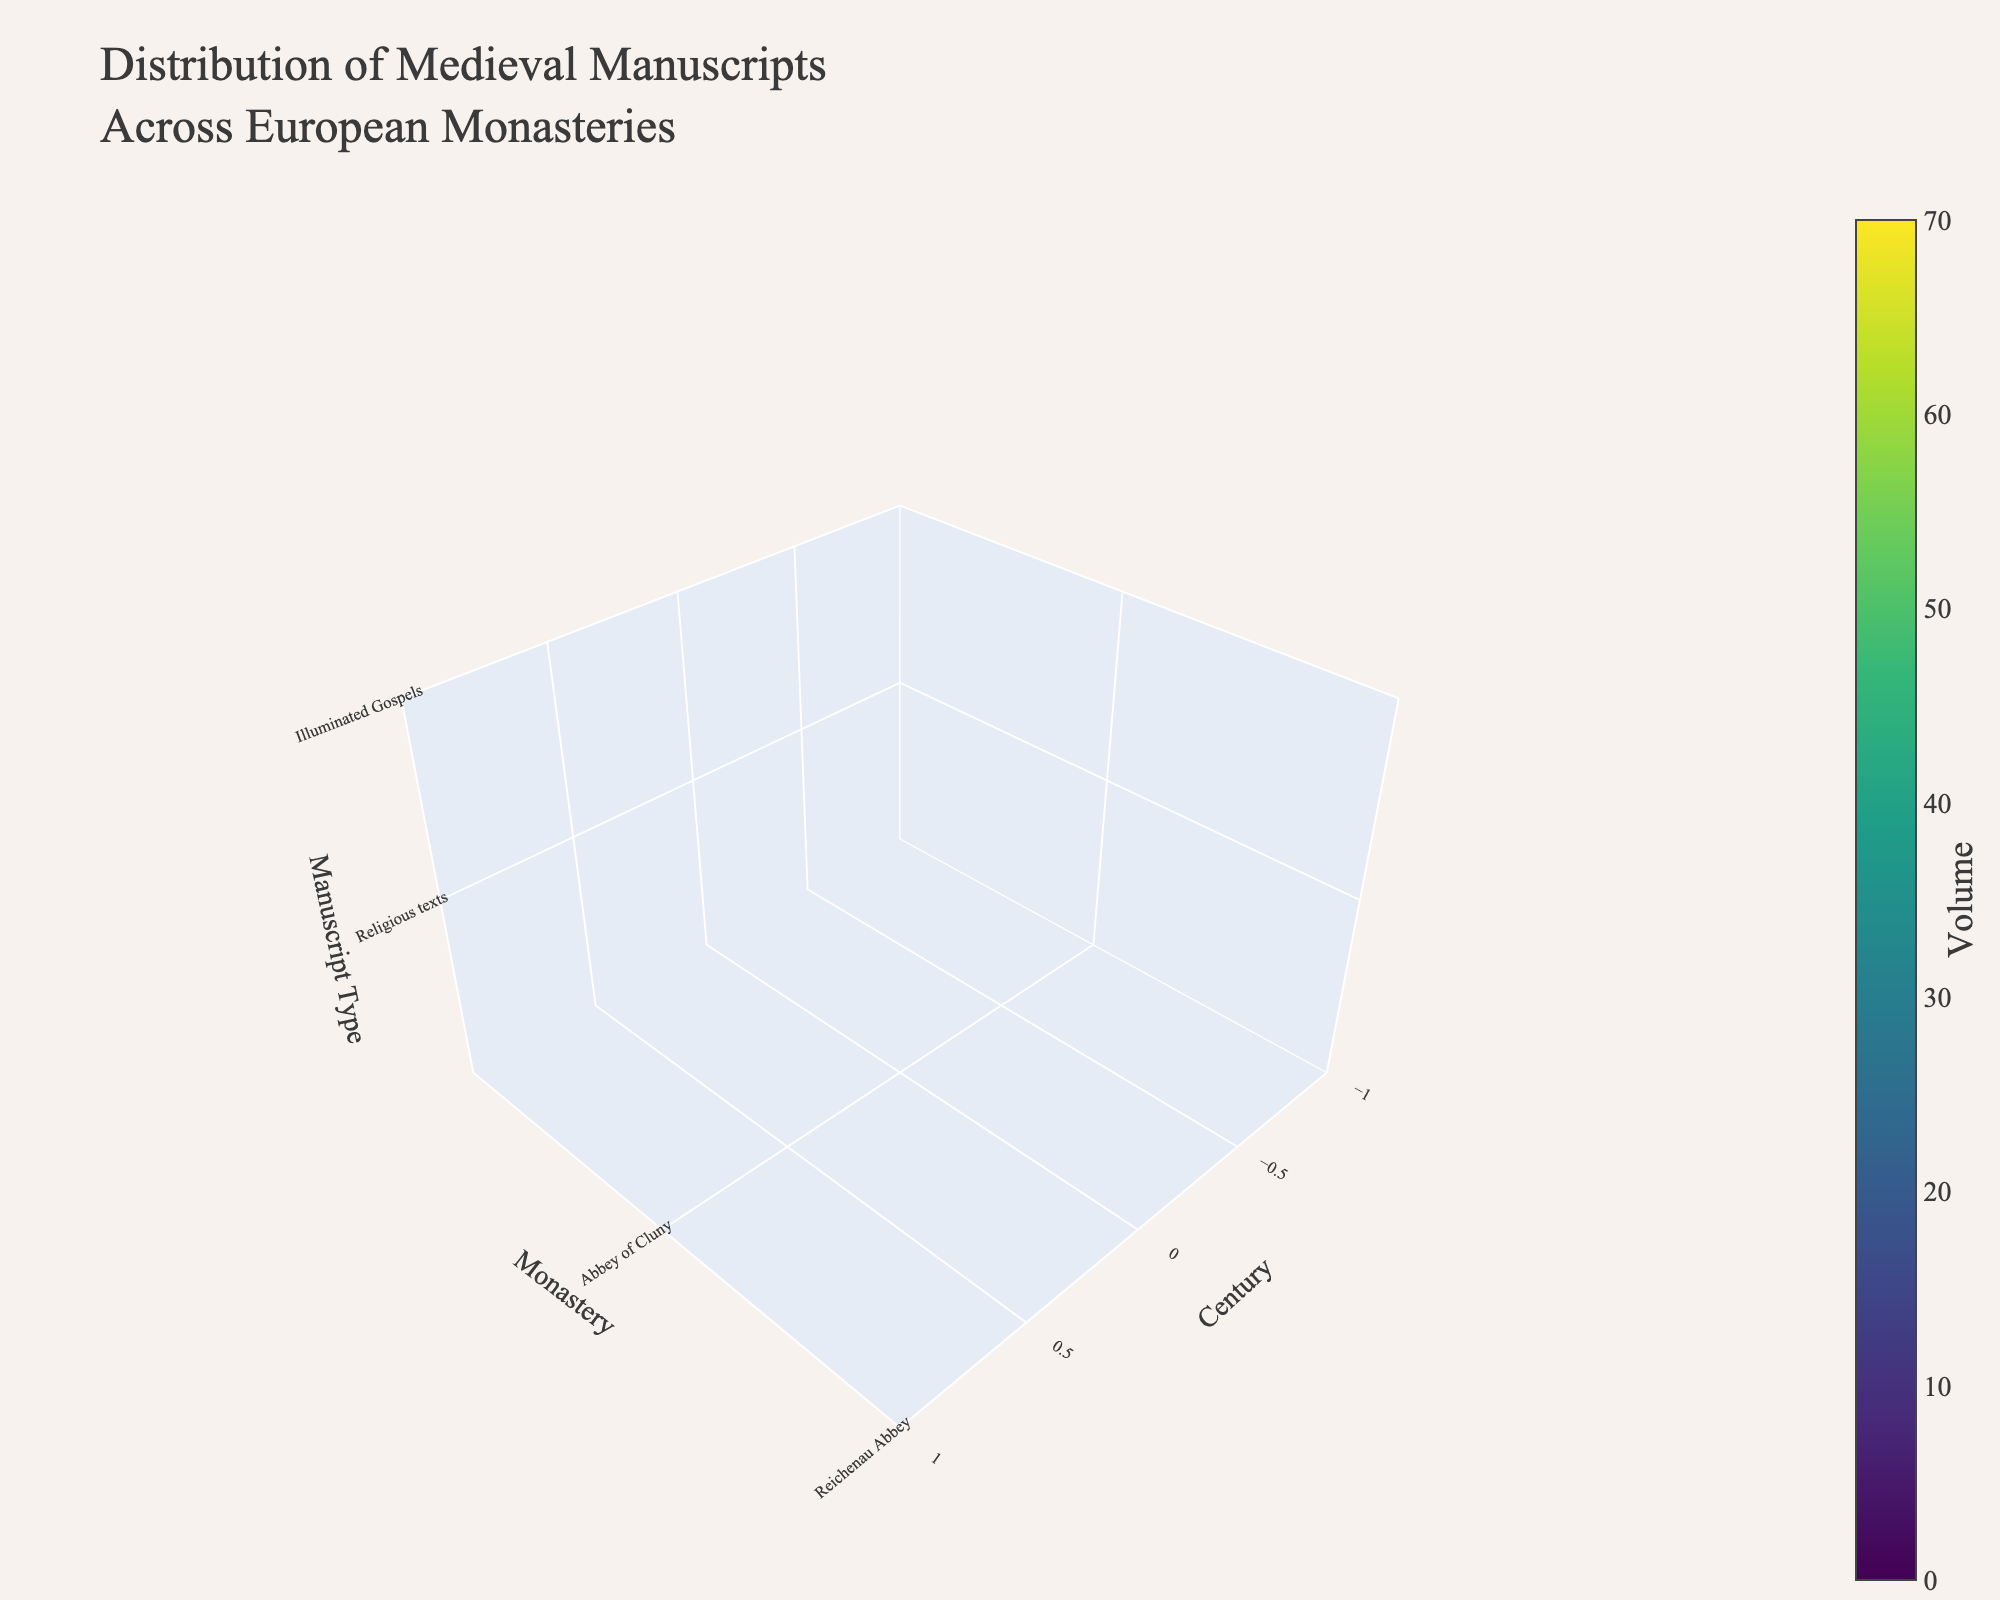How many centuries are represented in the plot? The plot's x-axis is labeled "Century" and spans across multiple points. By observing these points, one can count the distinct centuries.
Answer: 5 Which monastery has the highest volume of manuscripts in the 12th century? Locate the data points corresponding to the 12th century (x-axis) and identify the highest volume (color intensity) among the monasteries (y-axis).
Answer: Scriptorium of St. Gall How does the volume of illuminated gospels in Reichenau Abbey in the 11th century compare to the volume of liturgical books in the Scriptorium of St. Gall in the 12th century? Compare the volumes for the given monastery and manuscript type across the specified centuries by examining the color intensities at the respective 3D coordinates.
Answer: 32 (Reichenau Abbey, 11th century) < 58 (Scriptorium of St. Gall, 12th century) What's the average volume of manuscripts in the 13th century? For the 13th century, locate all the data points, sum their volumes, and divide by the number of data points. (63 + 41 + 35) / 3 = 139 / 3.
Answer: 46.33 Which century has the greatest variety of manuscript types represented? Look at the z-axis (manuscript types) for each century and count the unique types per century to determine which has the most variety.
Answer: 14th century Which manuscript type has the highest overall volume across all centuries and monasteries? Sum the volumes for each manuscript type across all centuries and monasteries and identify the type with the highest total.
Answer: Humanist texts Compare the volumes of scientific manuscripts in the Monastery of Santa Maria de Ripoll (13th century) and astronomical works in Monastery of El Escorial (15th century). Locate these specific data points in the plot and compare the respective volumes.
Answer: 35 (Santa Maria de Ripoll, 13th century) < 43 (El Escorial, 15th century) What is the total volume of religious texts documented in the plot across all centuries and monasteries? Locate all the data points for "Religious texts" across the plot and sum their volumes.
Answer: 45 How do the volumes of devotional texts in the Franciscan Convent of Assisi in the 14th century and humanist texts in the Abbey of Saint-Victor in the 15th century compare? Check the respective volumes of devotional texts and humanist texts in these places and centuries.
Answer: 47 (Franciscan Convent of Assisi) < 71 (Abbey of Saint-Victor) 